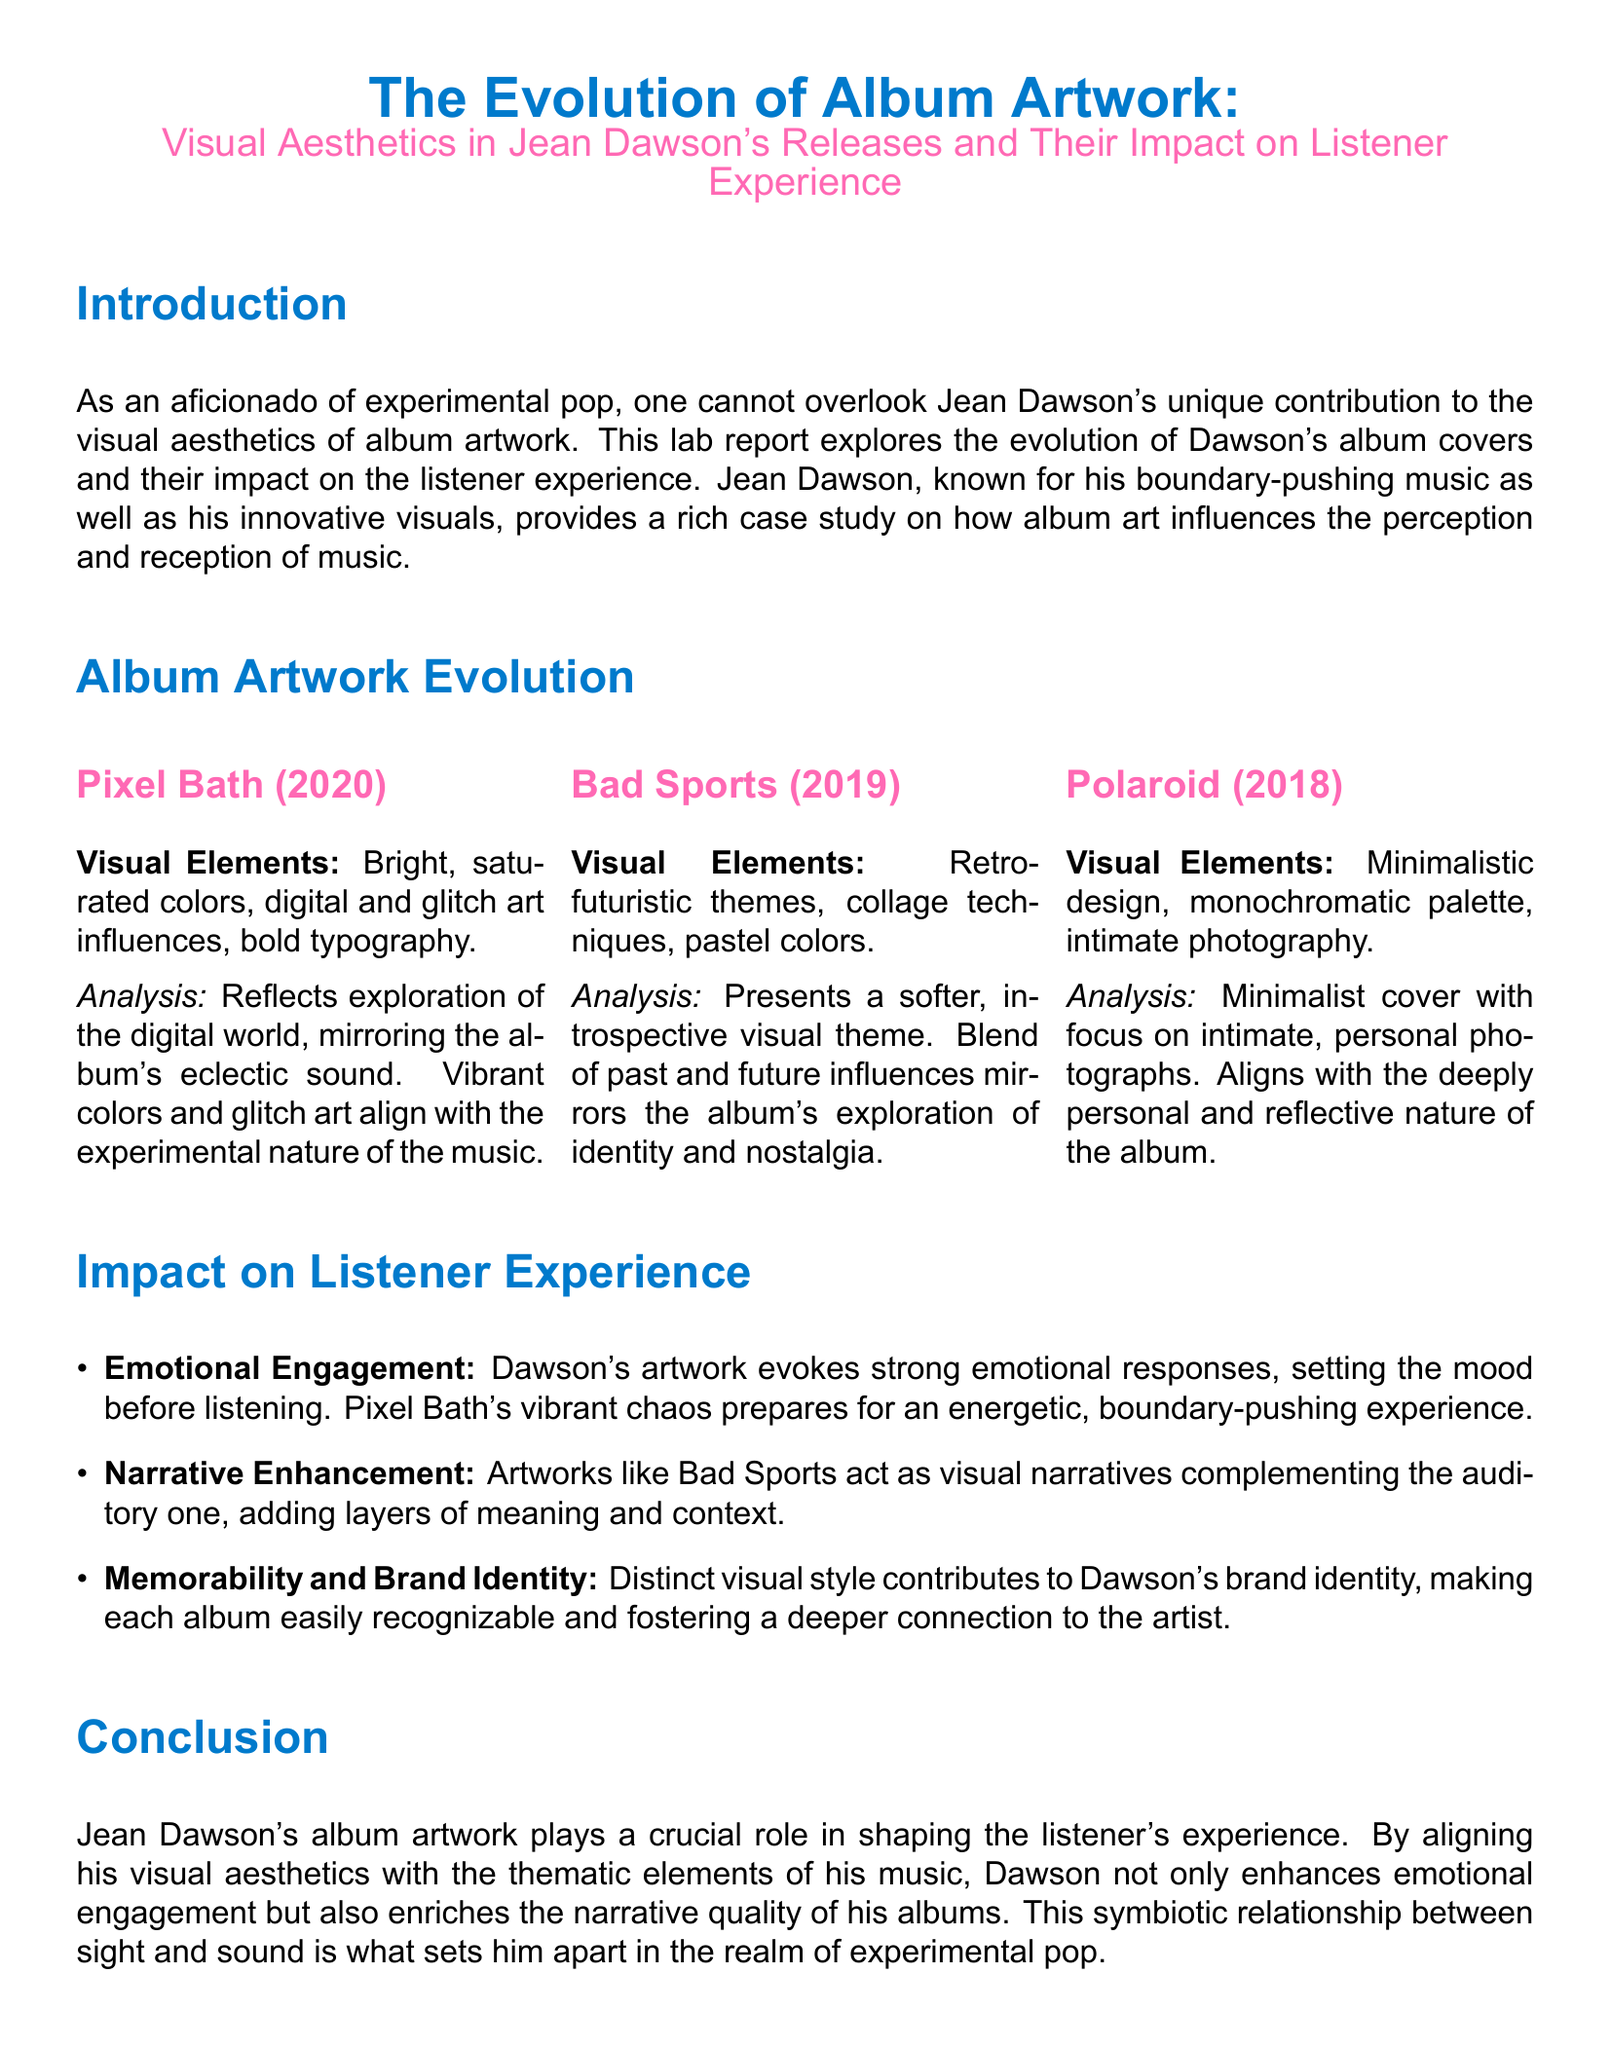what is the title of the lab report? The title of the lab report is stated at the beginning and is "The Evolution of Album Artwork: Visual Aesthetics in Jean Dawson's Releases and Their Impact on Listener Experience."
Answer: The Evolution of Album Artwork: Visual Aesthetics in Jean Dawson's Releases and Their Impact on Listener Experience what year was "Pixel Bath" released? The document lists the release year of "Pixel Bath" in the Album Artwork Evolution section, which is 2020.
Answer: 2020 which album features retro-futuristic themes? The document specifies that "Bad Sports" showcases retro-futuristic themes under the Album Artwork Evolution section.
Answer: Bad Sports what visual elements are highlighted for "Polaroid"? The report defines the visual elements for "Polaroid" as minimalistic design, monochromatic palette, and intimate photography.
Answer: minimalistic design, monochromatic palette, intimate photography how does Dawson's artwork affect emotional engagement? The document states that Dawson's artwork evokes strong emotional responses, influencing the listener's mood before listening.
Answer: evoking strong emotional responses what role does the album art play in brand identity? The report mentions that Dawson's distinct visual style contributes to his brand identity, making his albums recognizable.
Answer: contributes to brand identity which album is associated with vibrant chaos? The document connects "Pixel Bath" to vibrant chaos in the context of listener experience.
Answer: Pixel Bath what is the primary focus of the artwork for "Polaroid"? The document indicates that the focus of the artwork for "Polaroid" is on intimate, personal photographs.
Answer: intimate, personal photographs 